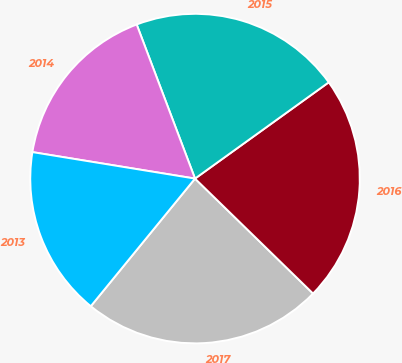Convert chart. <chart><loc_0><loc_0><loc_500><loc_500><pie_chart><fcel>2017<fcel>2016<fcel>2015<fcel>2014<fcel>2013<nl><fcel>23.61%<fcel>22.22%<fcel>20.83%<fcel>16.67%<fcel>16.67%<nl></chart> 